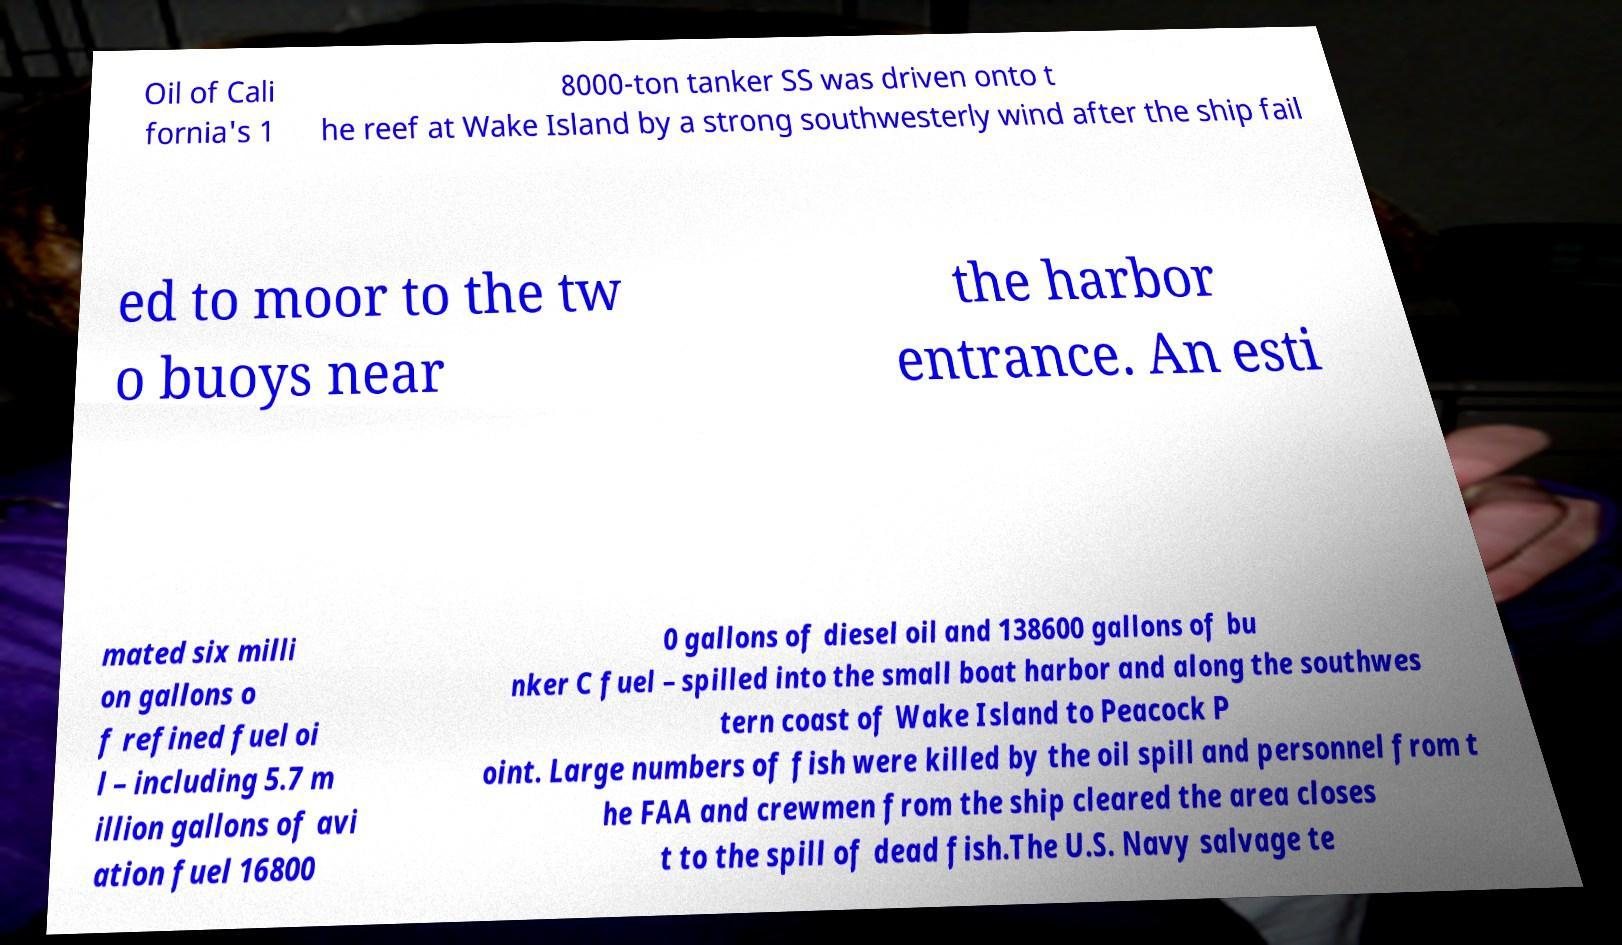For documentation purposes, I need the text within this image transcribed. Could you provide that? Oil of Cali fornia's 1 8000-ton tanker SS was driven onto t he reef at Wake Island by a strong southwesterly wind after the ship fail ed to moor to the tw o buoys near the harbor entrance. An esti mated six milli on gallons o f refined fuel oi l – including 5.7 m illion gallons of avi ation fuel 16800 0 gallons of diesel oil and 138600 gallons of bu nker C fuel – spilled into the small boat harbor and along the southwes tern coast of Wake Island to Peacock P oint. Large numbers of fish were killed by the oil spill and personnel from t he FAA and crewmen from the ship cleared the area closes t to the spill of dead fish.The U.S. Navy salvage te 